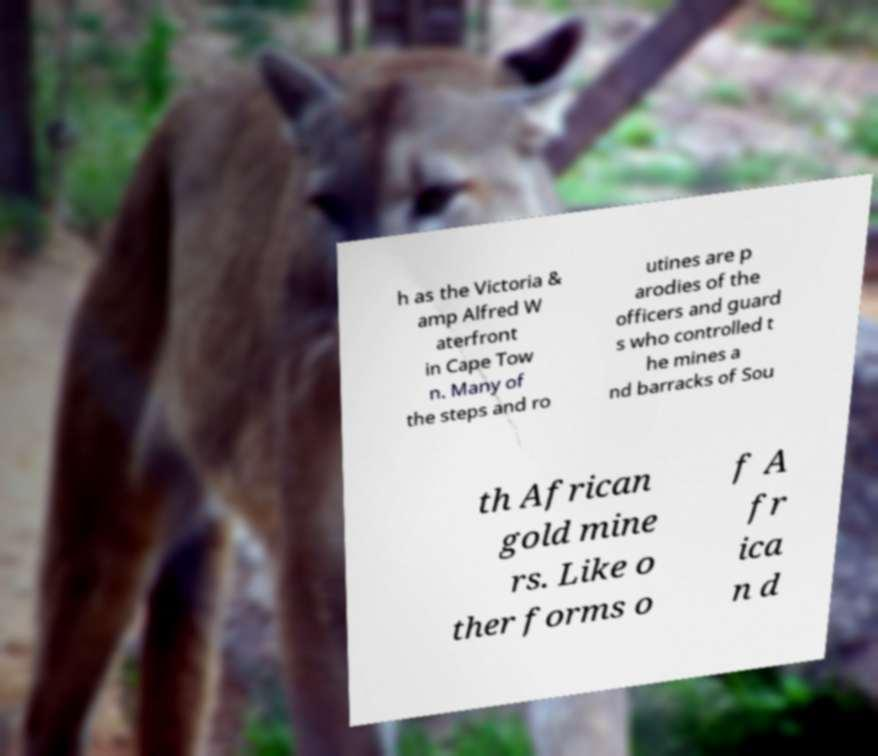Please read and relay the text visible in this image. What does it say? h as the Victoria & amp Alfred W aterfront in Cape Tow n. Many of the steps and ro utines are p arodies of the officers and guard s who controlled t he mines a nd barracks of Sou th African gold mine rs. Like o ther forms o f A fr ica n d 